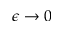<formula> <loc_0><loc_0><loc_500><loc_500>\epsilon \rightarrow 0</formula> 